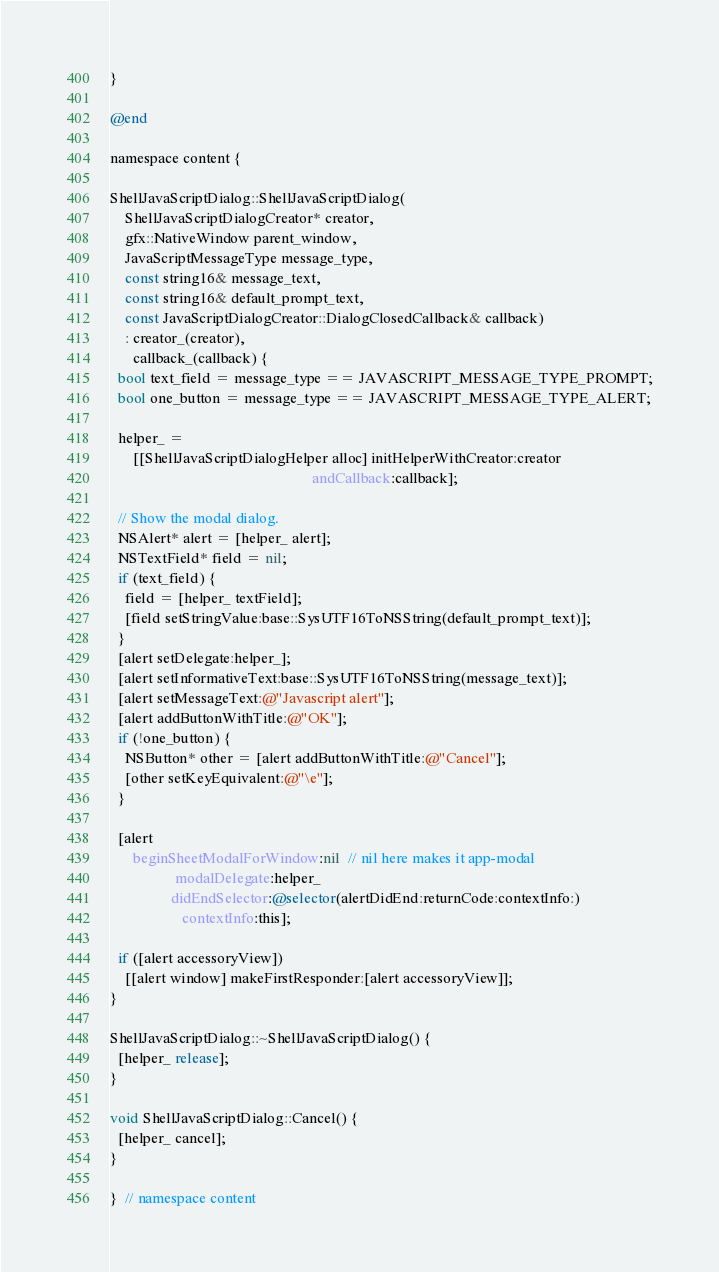<code> <loc_0><loc_0><loc_500><loc_500><_ObjectiveC_>}

@end

namespace content {

ShellJavaScriptDialog::ShellJavaScriptDialog(
    ShellJavaScriptDialogCreator* creator,
    gfx::NativeWindow parent_window,
    JavaScriptMessageType message_type,
    const string16& message_text,
    const string16& default_prompt_text,
    const JavaScriptDialogCreator::DialogClosedCallback& callback)
    : creator_(creator),
      callback_(callback) {
  bool text_field = message_type == JAVASCRIPT_MESSAGE_TYPE_PROMPT;
  bool one_button = message_type == JAVASCRIPT_MESSAGE_TYPE_ALERT;

  helper_ =
      [[ShellJavaScriptDialogHelper alloc] initHelperWithCreator:creator
                                                     andCallback:callback];

  // Show the modal dialog.
  NSAlert* alert = [helper_ alert];
  NSTextField* field = nil;
  if (text_field) {
    field = [helper_ textField];
    [field setStringValue:base::SysUTF16ToNSString(default_prompt_text)];
  }
  [alert setDelegate:helper_];
  [alert setInformativeText:base::SysUTF16ToNSString(message_text)];
  [alert setMessageText:@"Javascript alert"];
  [alert addButtonWithTitle:@"OK"];
  if (!one_button) {
    NSButton* other = [alert addButtonWithTitle:@"Cancel"];
    [other setKeyEquivalent:@"\e"];
  }

  [alert
      beginSheetModalForWindow:nil  // nil here makes it app-modal
                 modalDelegate:helper_
                didEndSelector:@selector(alertDidEnd:returnCode:contextInfo:)
                   contextInfo:this];

  if ([alert accessoryView])
    [[alert window] makeFirstResponder:[alert accessoryView]];
}

ShellJavaScriptDialog::~ShellJavaScriptDialog() {
  [helper_ release];
}

void ShellJavaScriptDialog::Cancel() {
  [helper_ cancel];
}

}  // namespace content
</code> 